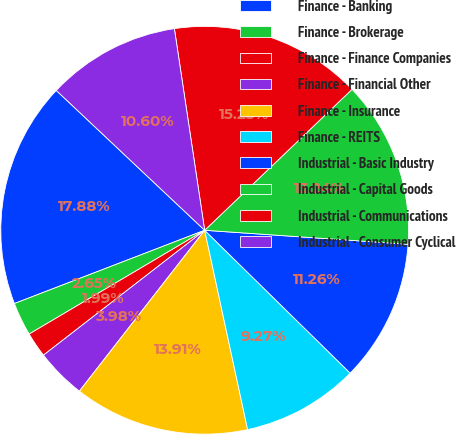Convert chart. <chart><loc_0><loc_0><loc_500><loc_500><pie_chart><fcel>Finance - Banking<fcel>Finance - Brokerage<fcel>Finance - Finance Companies<fcel>Finance - Financial Other<fcel>Finance - Insurance<fcel>Finance - REITS<fcel>Industrial - Basic Industry<fcel>Industrial - Capital Goods<fcel>Industrial - Communications<fcel>Industrial - Consumer Cyclical<nl><fcel>17.88%<fcel>2.65%<fcel>1.99%<fcel>3.98%<fcel>13.91%<fcel>9.27%<fcel>11.26%<fcel>13.24%<fcel>15.23%<fcel>10.6%<nl></chart> 